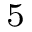Convert formula to latex. <formula><loc_0><loc_0><loc_500><loc_500>^ { 5 }</formula> 